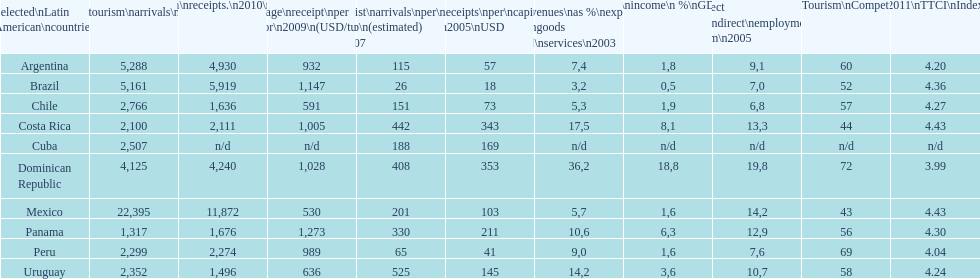What was the usual dollar amount brazil received for each tourist in 2009? 1,147. 